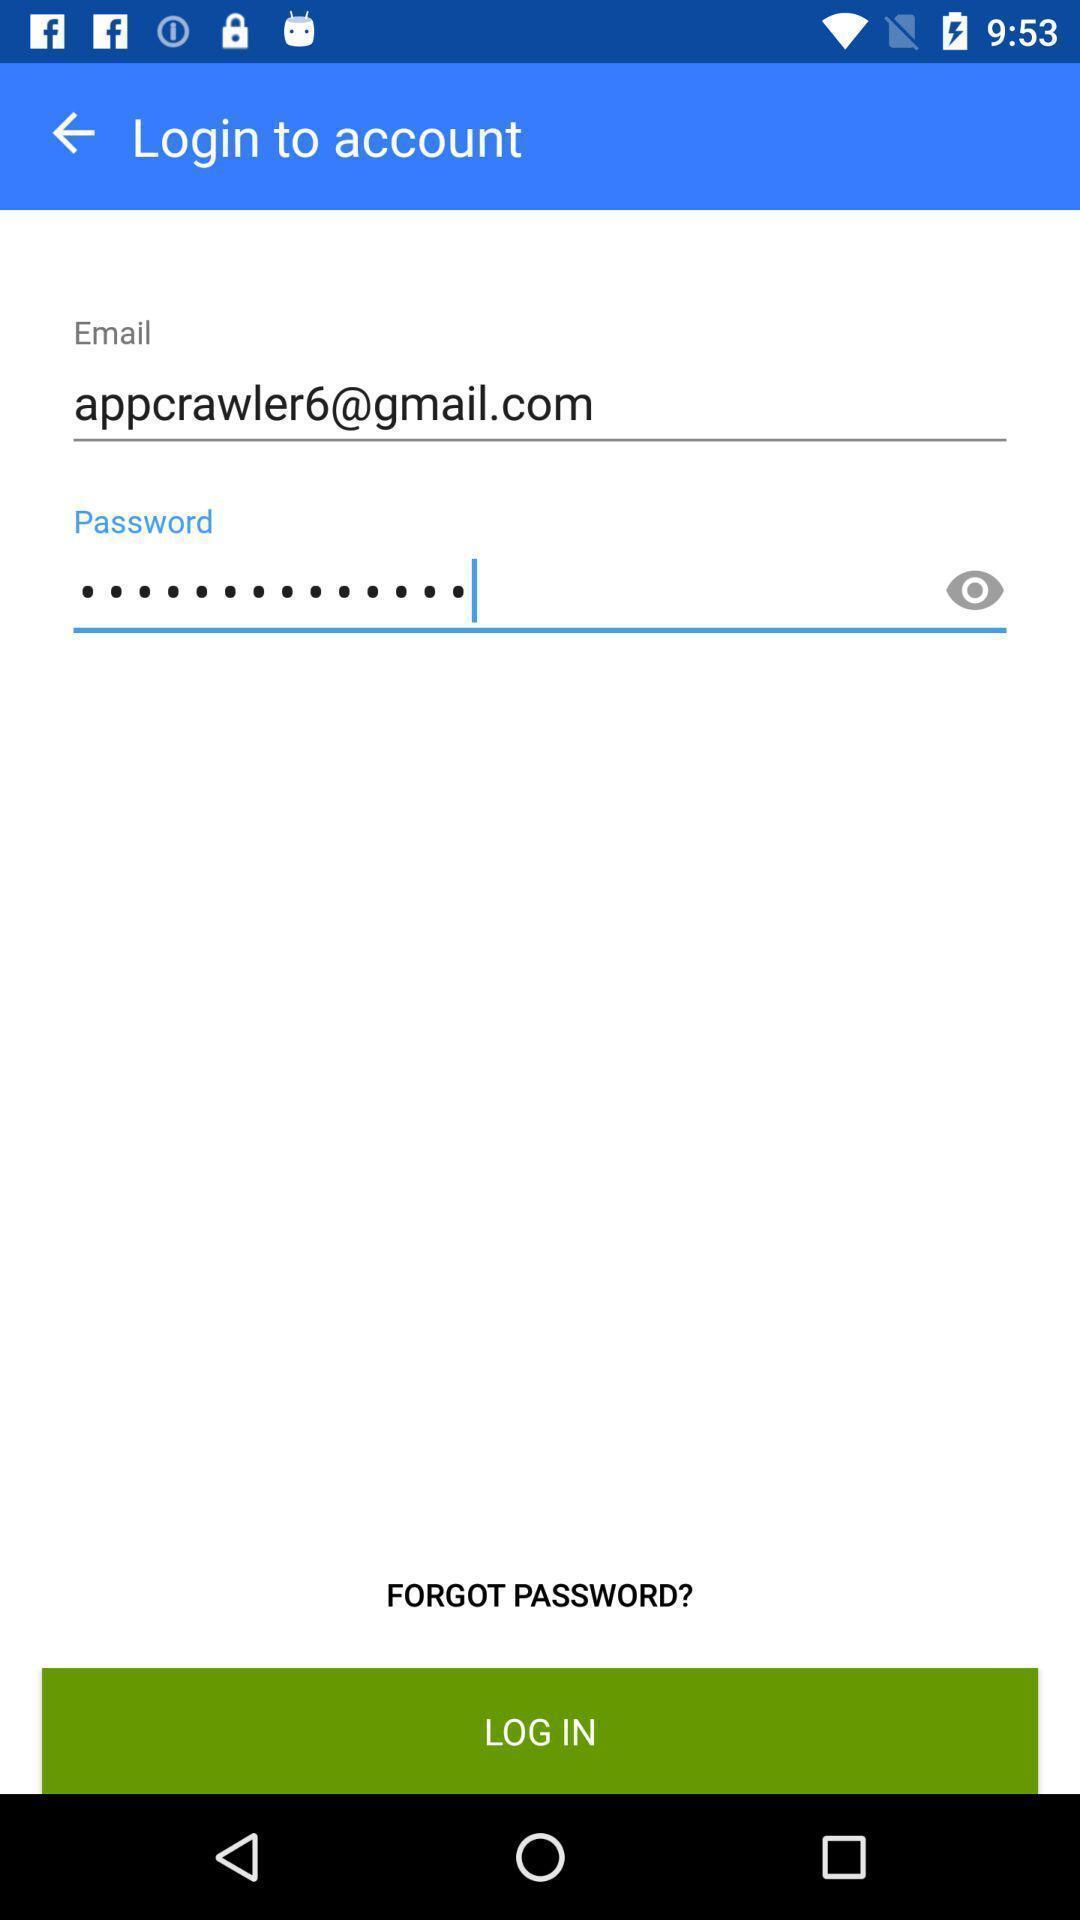What can you discern from this picture? Page displaying login credentials. 